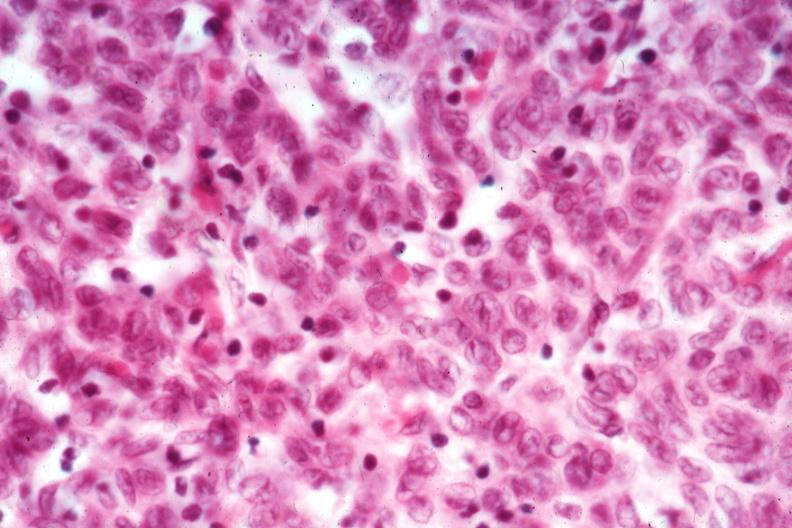does this image show cell detail good epithelial dominance?
Answer the question using a single word or phrase. Yes 